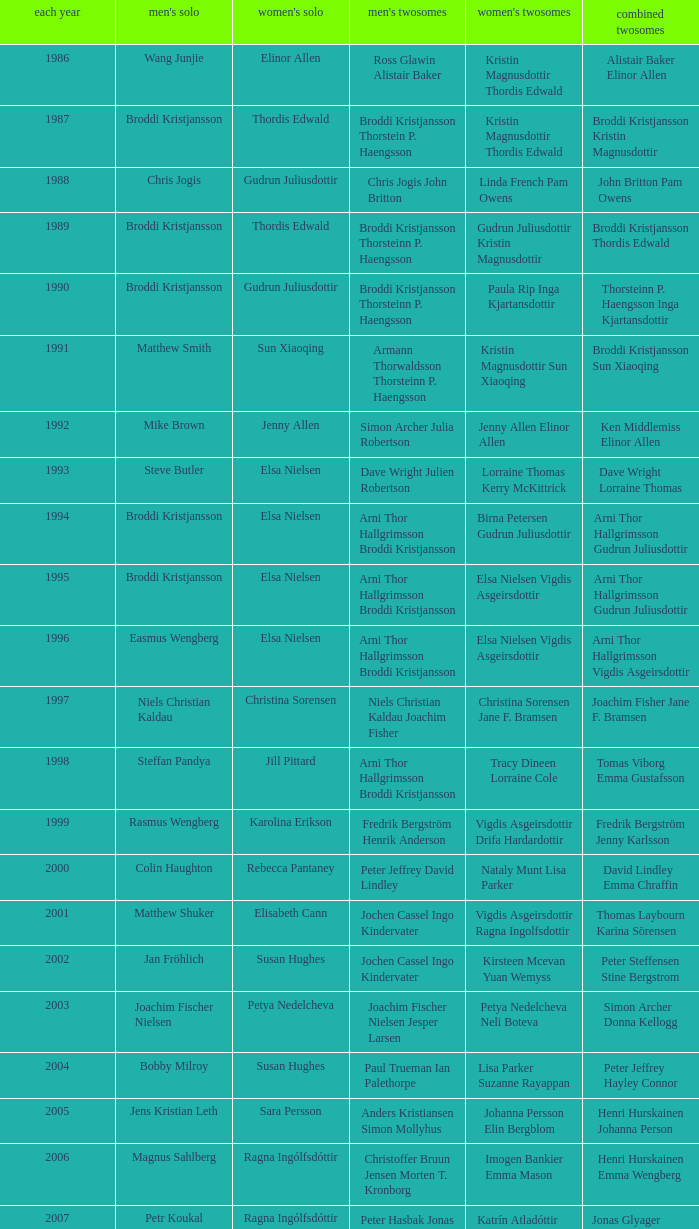In what mixed doubles did Niels Christian Kaldau play in men's singles? Joachim Fisher Jane F. Bramsen. 